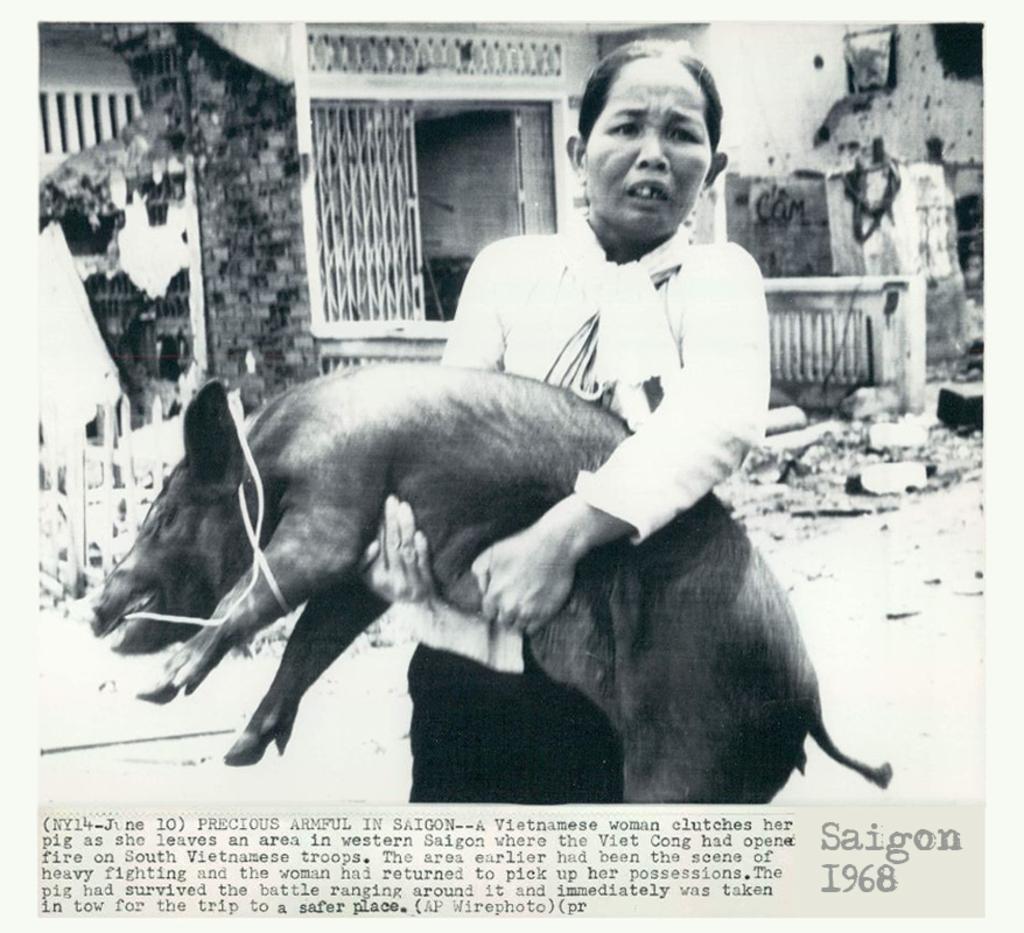Could you give a brief overview of what you see in this image? In this image we can see a woman holding pig in her hands. In the background there are buildings and grills. At the bottom of the image we can see text. 